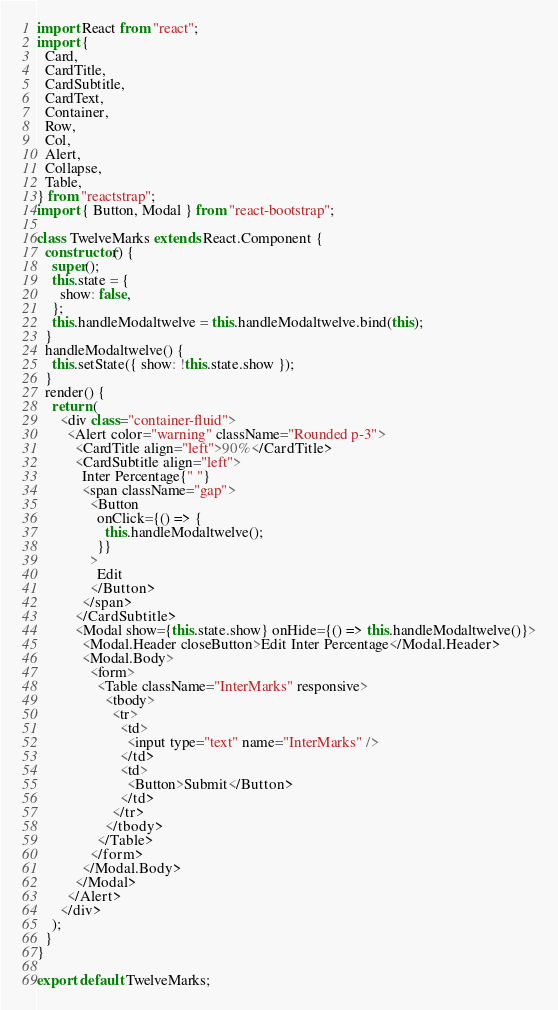Convert code to text. <code><loc_0><loc_0><loc_500><loc_500><_JavaScript_>import React from "react";
import {
  Card,
  CardTitle,
  CardSubtitle,
  CardText,
  Container,
  Row,
  Col,
  Alert,
  Collapse,
  Table,
} from "reactstrap";
import { Button, Modal } from "react-bootstrap";

class TwelveMarks extends React.Component {
  constructor() {
    super();
    this.state = {
      show: false,
    };
    this.handleModaltwelve = this.handleModaltwelve.bind(this);
  }
  handleModaltwelve() {
    this.setState({ show: !this.state.show });
  }
  render() {
    return (
      <div class="container-fluid">
        <Alert color="warning" className="Rounded p-3">
          <CardTitle align="left">90%</CardTitle>
          <CardSubtitle align="left">
            Inter Percentage{" "}
            <span className="gap">
              <Button
                onClick={() => {
                  this.handleModaltwelve();
                }}
              >
                Edit
              </Button>
            </span>
          </CardSubtitle>
          <Modal show={this.state.show} onHide={() => this.handleModaltwelve()}>
            <Modal.Header closeButton>Edit Inter Percentage</Modal.Header>
            <Modal.Body>
              <form>
                <Table className="InterMarks" responsive>
                  <tbody>
                    <tr>
                      <td>
                        <input type="text" name="InterMarks" />
                      </td>
                      <td>
                        <Button>Submit</Button>
                      </td>
                    </tr>
                  </tbody>
                </Table>
              </form>
            </Modal.Body>
          </Modal>
        </Alert>
      </div>
    );
  }
}

export default TwelveMarks;
</code> 